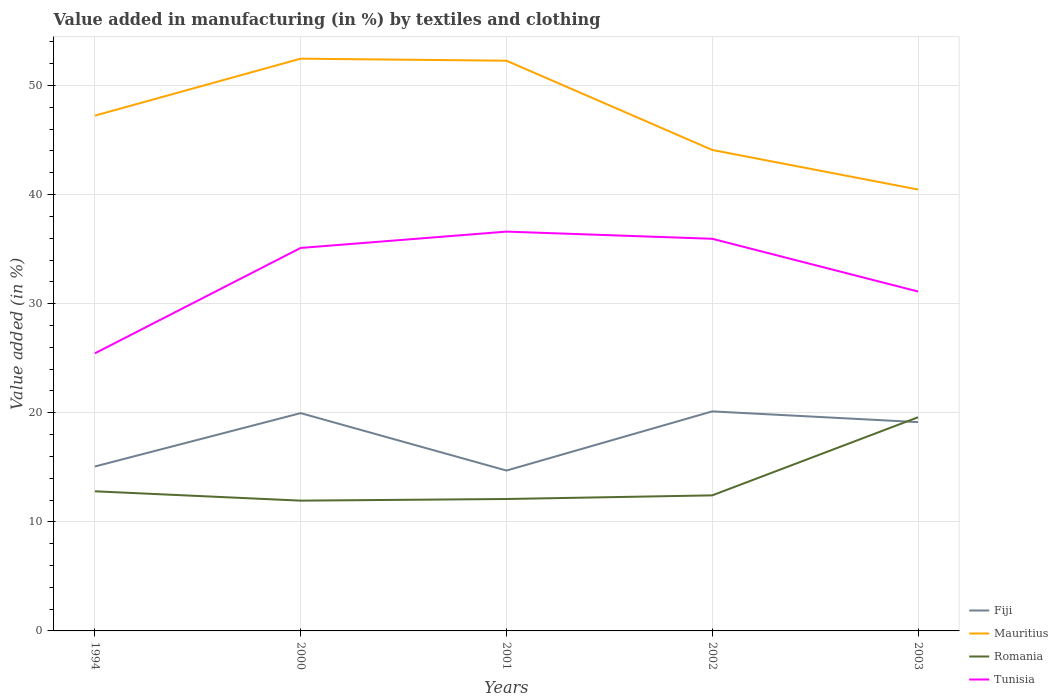Is the number of lines equal to the number of legend labels?
Your answer should be very brief. Yes. Across all years, what is the maximum percentage of value added in manufacturing by textiles and clothing in Mauritius?
Provide a succinct answer. 40.47. In which year was the percentage of value added in manufacturing by textiles and clothing in Fiji maximum?
Ensure brevity in your answer.  2001. What is the total percentage of value added in manufacturing by textiles and clothing in Fiji in the graph?
Keep it short and to the point. -5.42. What is the difference between the highest and the second highest percentage of value added in manufacturing by textiles and clothing in Mauritius?
Your answer should be very brief. 11.99. What is the difference between the highest and the lowest percentage of value added in manufacturing by textiles and clothing in Tunisia?
Your answer should be compact. 3. Is the percentage of value added in manufacturing by textiles and clothing in Mauritius strictly greater than the percentage of value added in manufacturing by textiles and clothing in Fiji over the years?
Your answer should be compact. No. How many lines are there?
Your answer should be very brief. 4. What is the difference between two consecutive major ticks on the Y-axis?
Your answer should be compact. 10. Does the graph contain any zero values?
Make the answer very short. No. Does the graph contain grids?
Give a very brief answer. Yes. Where does the legend appear in the graph?
Offer a terse response. Bottom right. How are the legend labels stacked?
Ensure brevity in your answer.  Vertical. What is the title of the graph?
Provide a succinct answer. Value added in manufacturing (in %) by textiles and clothing. Does "Uganda" appear as one of the legend labels in the graph?
Give a very brief answer. No. What is the label or title of the X-axis?
Offer a very short reply. Years. What is the label or title of the Y-axis?
Offer a very short reply. Value added (in %). What is the Value added (in %) of Fiji in 1994?
Offer a very short reply. 15.07. What is the Value added (in %) in Mauritius in 1994?
Your answer should be compact. 47.24. What is the Value added (in %) of Romania in 1994?
Offer a terse response. 12.8. What is the Value added (in %) of Tunisia in 1994?
Make the answer very short. 25.45. What is the Value added (in %) in Fiji in 2000?
Make the answer very short. 19.97. What is the Value added (in %) in Mauritius in 2000?
Provide a succinct answer. 52.46. What is the Value added (in %) of Romania in 2000?
Offer a terse response. 11.94. What is the Value added (in %) of Tunisia in 2000?
Your response must be concise. 35.11. What is the Value added (in %) of Fiji in 2001?
Make the answer very short. 14.7. What is the Value added (in %) in Mauritius in 2001?
Offer a very short reply. 52.27. What is the Value added (in %) of Romania in 2001?
Give a very brief answer. 12.09. What is the Value added (in %) of Tunisia in 2001?
Make the answer very short. 36.61. What is the Value added (in %) in Fiji in 2002?
Offer a very short reply. 20.13. What is the Value added (in %) in Mauritius in 2002?
Your answer should be compact. 44.09. What is the Value added (in %) of Romania in 2002?
Provide a short and direct response. 12.43. What is the Value added (in %) of Tunisia in 2002?
Your answer should be very brief. 35.95. What is the Value added (in %) in Fiji in 2003?
Make the answer very short. 19.14. What is the Value added (in %) of Mauritius in 2003?
Give a very brief answer. 40.47. What is the Value added (in %) in Romania in 2003?
Offer a terse response. 19.59. What is the Value added (in %) of Tunisia in 2003?
Provide a short and direct response. 31.11. Across all years, what is the maximum Value added (in %) of Fiji?
Keep it short and to the point. 20.13. Across all years, what is the maximum Value added (in %) of Mauritius?
Your answer should be compact. 52.46. Across all years, what is the maximum Value added (in %) of Romania?
Offer a terse response. 19.59. Across all years, what is the maximum Value added (in %) of Tunisia?
Offer a very short reply. 36.61. Across all years, what is the minimum Value added (in %) in Fiji?
Offer a terse response. 14.7. Across all years, what is the minimum Value added (in %) in Mauritius?
Your answer should be compact. 40.47. Across all years, what is the minimum Value added (in %) in Romania?
Keep it short and to the point. 11.94. Across all years, what is the minimum Value added (in %) of Tunisia?
Make the answer very short. 25.45. What is the total Value added (in %) in Fiji in the graph?
Offer a terse response. 89.01. What is the total Value added (in %) of Mauritius in the graph?
Provide a short and direct response. 236.53. What is the total Value added (in %) in Romania in the graph?
Your answer should be very brief. 68.85. What is the total Value added (in %) of Tunisia in the graph?
Your answer should be very brief. 164.22. What is the difference between the Value added (in %) in Fiji in 1994 and that in 2000?
Your answer should be very brief. -4.89. What is the difference between the Value added (in %) in Mauritius in 1994 and that in 2000?
Give a very brief answer. -5.22. What is the difference between the Value added (in %) of Romania in 1994 and that in 2000?
Your answer should be very brief. 0.86. What is the difference between the Value added (in %) in Tunisia in 1994 and that in 2000?
Keep it short and to the point. -9.66. What is the difference between the Value added (in %) in Fiji in 1994 and that in 2001?
Provide a succinct answer. 0.37. What is the difference between the Value added (in %) in Mauritius in 1994 and that in 2001?
Provide a succinct answer. -5.04. What is the difference between the Value added (in %) of Romania in 1994 and that in 2001?
Your response must be concise. 0.71. What is the difference between the Value added (in %) in Tunisia in 1994 and that in 2001?
Make the answer very short. -11.16. What is the difference between the Value added (in %) of Fiji in 1994 and that in 2002?
Give a very brief answer. -5.05. What is the difference between the Value added (in %) in Mauritius in 1994 and that in 2002?
Provide a short and direct response. 3.15. What is the difference between the Value added (in %) in Romania in 1994 and that in 2002?
Give a very brief answer. 0.37. What is the difference between the Value added (in %) in Tunisia in 1994 and that in 2002?
Offer a terse response. -10.5. What is the difference between the Value added (in %) in Fiji in 1994 and that in 2003?
Offer a very short reply. -4.07. What is the difference between the Value added (in %) in Mauritius in 1994 and that in 2003?
Your answer should be very brief. 6.77. What is the difference between the Value added (in %) of Romania in 1994 and that in 2003?
Make the answer very short. -6.79. What is the difference between the Value added (in %) in Tunisia in 1994 and that in 2003?
Ensure brevity in your answer.  -5.67. What is the difference between the Value added (in %) in Fiji in 2000 and that in 2001?
Your answer should be very brief. 5.26. What is the difference between the Value added (in %) in Mauritius in 2000 and that in 2001?
Give a very brief answer. 0.19. What is the difference between the Value added (in %) in Romania in 2000 and that in 2001?
Give a very brief answer. -0.15. What is the difference between the Value added (in %) in Tunisia in 2000 and that in 2001?
Provide a short and direct response. -1.5. What is the difference between the Value added (in %) in Fiji in 2000 and that in 2002?
Offer a very short reply. -0.16. What is the difference between the Value added (in %) in Mauritius in 2000 and that in 2002?
Offer a very short reply. 8.37. What is the difference between the Value added (in %) of Romania in 2000 and that in 2002?
Your answer should be compact. -0.48. What is the difference between the Value added (in %) of Tunisia in 2000 and that in 2002?
Provide a short and direct response. -0.84. What is the difference between the Value added (in %) of Fiji in 2000 and that in 2003?
Make the answer very short. 0.82. What is the difference between the Value added (in %) in Mauritius in 2000 and that in 2003?
Provide a short and direct response. 11.99. What is the difference between the Value added (in %) of Romania in 2000 and that in 2003?
Make the answer very short. -7.64. What is the difference between the Value added (in %) in Tunisia in 2000 and that in 2003?
Keep it short and to the point. 3.99. What is the difference between the Value added (in %) of Fiji in 2001 and that in 2002?
Your response must be concise. -5.42. What is the difference between the Value added (in %) of Mauritius in 2001 and that in 2002?
Offer a terse response. 8.18. What is the difference between the Value added (in %) of Romania in 2001 and that in 2002?
Provide a succinct answer. -0.33. What is the difference between the Value added (in %) of Tunisia in 2001 and that in 2002?
Make the answer very short. 0.66. What is the difference between the Value added (in %) of Fiji in 2001 and that in 2003?
Make the answer very short. -4.44. What is the difference between the Value added (in %) in Mauritius in 2001 and that in 2003?
Provide a short and direct response. 11.81. What is the difference between the Value added (in %) in Romania in 2001 and that in 2003?
Ensure brevity in your answer.  -7.49. What is the difference between the Value added (in %) of Tunisia in 2001 and that in 2003?
Keep it short and to the point. 5.49. What is the difference between the Value added (in %) of Fiji in 2002 and that in 2003?
Your response must be concise. 0.98. What is the difference between the Value added (in %) of Mauritius in 2002 and that in 2003?
Your answer should be very brief. 3.63. What is the difference between the Value added (in %) in Romania in 2002 and that in 2003?
Keep it short and to the point. -7.16. What is the difference between the Value added (in %) of Tunisia in 2002 and that in 2003?
Ensure brevity in your answer.  4.83. What is the difference between the Value added (in %) of Fiji in 1994 and the Value added (in %) of Mauritius in 2000?
Provide a short and direct response. -37.39. What is the difference between the Value added (in %) of Fiji in 1994 and the Value added (in %) of Romania in 2000?
Provide a succinct answer. 3.13. What is the difference between the Value added (in %) of Fiji in 1994 and the Value added (in %) of Tunisia in 2000?
Your answer should be compact. -20.04. What is the difference between the Value added (in %) of Mauritius in 1994 and the Value added (in %) of Romania in 2000?
Provide a short and direct response. 35.29. What is the difference between the Value added (in %) in Mauritius in 1994 and the Value added (in %) in Tunisia in 2000?
Provide a short and direct response. 12.13. What is the difference between the Value added (in %) in Romania in 1994 and the Value added (in %) in Tunisia in 2000?
Provide a short and direct response. -22.31. What is the difference between the Value added (in %) of Fiji in 1994 and the Value added (in %) of Mauritius in 2001?
Ensure brevity in your answer.  -37.2. What is the difference between the Value added (in %) in Fiji in 1994 and the Value added (in %) in Romania in 2001?
Offer a terse response. 2.98. What is the difference between the Value added (in %) in Fiji in 1994 and the Value added (in %) in Tunisia in 2001?
Ensure brevity in your answer.  -21.53. What is the difference between the Value added (in %) of Mauritius in 1994 and the Value added (in %) of Romania in 2001?
Give a very brief answer. 35.14. What is the difference between the Value added (in %) in Mauritius in 1994 and the Value added (in %) in Tunisia in 2001?
Your answer should be very brief. 10.63. What is the difference between the Value added (in %) of Romania in 1994 and the Value added (in %) of Tunisia in 2001?
Keep it short and to the point. -23.81. What is the difference between the Value added (in %) of Fiji in 1994 and the Value added (in %) of Mauritius in 2002?
Offer a very short reply. -29.02. What is the difference between the Value added (in %) of Fiji in 1994 and the Value added (in %) of Romania in 2002?
Ensure brevity in your answer.  2.64. What is the difference between the Value added (in %) in Fiji in 1994 and the Value added (in %) in Tunisia in 2002?
Ensure brevity in your answer.  -20.88. What is the difference between the Value added (in %) of Mauritius in 1994 and the Value added (in %) of Romania in 2002?
Ensure brevity in your answer.  34.81. What is the difference between the Value added (in %) in Mauritius in 1994 and the Value added (in %) in Tunisia in 2002?
Offer a very short reply. 11.29. What is the difference between the Value added (in %) in Romania in 1994 and the Value added (in %) in Tunisia in 2002?
Your answer should be compact. -23.15. What is the difference between the Value added (in %) of Fiji in 1994 and the Value added (in %) of Mauritius in 2003?
Give a very brief answer. -25.39. What is the difference between the Value added (in %) in Fiji in 1994 and the Value added (in %) in Romania in 2003?
Offer a terse response. -4.51. What is the difference between the Value added (in %) of Fiji in 1994 and the Value added (in %) of Tunisia in 2003?
Give a very brief answer. -16.04. What is the difference between the Value added (in %) of Mauritius in 1994 and the Value added (in %) of Romania in 2003?
Provide a succinct answer. 27.65. What is the difference between the Value added (in %) of Mauritius in 1994 and the Value added (in %) of Tunisia in 2003?
Your answer should be very brief. 16.12. What is the difference between the Value added (in %) in Romania in 1994 and the Value added (in %) in Tunisia in 2003?
Keep it short and to the point. -18.31. What is the difference between the Value added (in %) of Fiji in 2000 and the Value added (in %) of Mauritius in 2001?
Provide a succinct answer. -32.31. What is the difference between the Value added (in %) of Fiji in 2000 and the Value added (in %) of Romania in 2001?
Provide a succinct answer. 7.87. What is the difference between the Value added (in %) of Fiji in 2000 and the Value added (in %) of Tunisia in 2001?
Provide a short and direct response. -16.64. What is the difference between the Value added (in %) of Mauritius in 2000 and the Value added (in %) of Romania in 2001?
Your answer should be compact. 40.37. What is the difference between the Value added (in %) in Mauritius in 2000 and the Value added (in %) in Tunisia in 2001?
Provide a succinct answer. 15.85. What is the difference between the Value added (in %) of Romania in 2000 and the Value added (in %) of Tunisia in 2001?
Provide a short and direct response. -24.66. What is the difference between the Value added (in %) in Fiji in 2000 and the Value added (in %) in Mauritius in 2002?
Make the answer very short. -24.12. What is the difference between the Value added (in %) of Fiji in 2000 and the Value added (in %) of Romania in 2002?
Your answer should be compact. 7.54. What is the difference between the Value added (in %) in Fiji in 2000 and the Value added (in %) in Tunisia in 2002?
Your response must be concise. -15.98. What is the difference between the Value added (in %) in Mauritius in 2000 and the Value added (in %) in Romania in 2002?
Your answer should be compact. 40.03. What is the difference between the Value added (in %) in Mauritius in 2000 and the Value added (in %) in Tunisia in 2002?
Your answer should be very brief. 16.51. What is the difference between the Value added (in %) in Romania in 2000 and the Value added (in %) in Tunisia in 2002?
Ensure brevity in your answer.  -24. What is the difference between the Value added (in %) in Fiji in 2000 and the Value added (in %) in Mauritius in 2003?
Your answer should be very brief. -20.5. What is the difference between the Value added (in %) of Fiji in 2000 and the Value added (in %) of Romania in 2003?
Your answer should be very brief. 0.38. What is the difference between the Value added (in %) in Fiji in 2000 and the Value added (in %) in Tunisia in 2003?
Ensure brevity in your answer.  -11.15. What is the difference between the Value added (in %) in Mauritius in 2000 and the Value added (in %) in Romania in 2003?
Ensure brevity in your answer.  32.87. What is the difference between the Value added (in %) of Mauritius in 2000 and the Value added (in %) of Tunisia in 2003?
Ensure brevity in your answer.  21.35. What is the difference between the Value added (in %) in Romania in 2000 and the Value added (in %) in Tunisia in 2003?
Keep it short and to the point. -19.17. What is the difference between the Value added (in %) of Fiji in 2001 and the Value added (in %) of Mauritius in 2002?
Your response must be concise. -29.39. What is the difference between the Value added (in %) of Fiji in 2001 and the Value added (in %) of Romania in 2002?
Your answer should be compact. 2.27. What is the difference between the Value added (in %) in Fiji in 2001 and the Value added (in %) in Tunisia in 2002?
Provide a succinct answer. -21.25. What is the difference between the Value added (in %) in Mauritius in 2001 and the Value added (in %) in Romania in 2002?
Ensure brevity in your answer.  39.85. What is the difference between the Value added (in %) in Mauritius in 2001 and the Value added (in %) in Tunisia in 2002?
Your answer should be compact. 16.33. What is the difference between the Value added (in %) of Romania in 2001 and the Value added (in %) of Tunisia in 2002?
Ensure brevity in your answer.  -23.85. What is the difference between the Value added (in %) in Fiji in 2001 and the Value added (in %) in Mauritius in 2003?
Your response must be concise. -25.76. What is the difference between the Value added (in %) in Fiji in 2001 and the Value added (in %) in Romania in 2003?
Ensure brevity in your answer.  -4.88. What is the difference between the Value added (in %) in Fiji in 2001 and the Value added (in %) in Tunisia in 2003?
Your answer should be very brief. -16.41. What is the difference between the Value added (in %) of Mauritius in 2001 and the Value added (in %) of Romania in 2003?
Keep it short and to the point. 32.69. What is the difference between the Value added (in %) in Mauritius in 2001 and the Value added (in %) in Tunisia in 2003?
Offer a very short reply. 21.16. What is the difference between the Value added (in %) of Romania in 2001 and the Value added (in %) of Tunisia in 2003?
Offer a terse response. -19.02. What is the difference between the Value added (in %) in Fiji in 2002 and the Value added (in %) in Mauritius in 2003?
Ensure brevity in your answer.  -20.34. What is the difference between the Value added (in %) in Fiji in 2002 and the Value added (in %) in Romania in 2003?
Your answer should be compact. 0.54. What is the difference between the Value added (in %) in Fiji in 2002 and the Value added (in %) in Tunisia in 2003?
Provide a short and direct response. -10.99. What is the difference between the Value added (in %) in Mauritius in 2002 and the Value added (in %) in Romania in 2003?
Offer a terse response. 24.5. What is the difference between the Value added (in %) in Mauritius in 2002 and the Value added (in %) in Tunisia in 2003?
Your answer should be very brief. 12.98. What is the difference between the Value added (in %) in Romania in 2002 and the Value added (in %) in Tunisia in 2003?
Offer a terse response. -18.69. What is the average Value added (in %) of Fiji per year?
Your answer should be compact. 17.8. What is the average Value added (in %) in Mauritius per year?
Ensure brevity in your answer.  47.3. What is the average Value added (in %) in Romania per year?
Provide a short and direct response. 13.77. What is the average Value added (in %) in Tunisia per year?
Ensure brevity in your answer.  32.84. In the year 1994, what is the difference between the Value added (in %) of Fiji and Value added (in %) of Mauritius?
Offer a very short reply. -32.17. In the year 1994, what is the difference between the Value added (in %) of Fiji and Value added (in %) of Romania?
Make the answer very short. 2.27. In the year 1994, what is the difference between the Value added (in %) in Fiji and Value added (in %) in Tunisia?
Provide a short and direct response. -10.38. In the year 1994, what is the difference between the Value added (in %) in Mauritius and Value added (in %) in Romania?
Ensure brevity in your answer.  34.44. In the year 1994, what is the difference between the Value added (in %) in Mauritius and Value added (in %) in Tunisia?
Your answer should be compact. 21.79. In the year 1994, what is the difference between the Value added (in %) of Romania and Value added (in %) of Tunisia?
Give a very brief answer. -12.65. In the year 2000, what is the difference between the Value added (in %) in Fiji and Value added (in %) in Mauritius?
Your answer should be very brief. -32.49. In the year 2000, what is the difference between the Value added (in %) of Fiji and Value added (in %) of Romania?
Your answer should be compact. 8.02. In the year 2000, what is the difference between the Value added (in %) of Fiji and Value added (in %) of Tunisia?
Offer a terse response. -15.14. In the year 2000, what is the difference between the Value added (in %) of Mauritius and Value added (in %) of Romania?
Your answer should be very brief. 40.52. In the year 2000, what is the difference between the Value added (in %) in Mauritius and Value added (in %) in Tunisia?
Ensure brevity in your answer.  17.35. In the year 2000, what is the difference between the Value added (in %) in Romania and Value added (in %) in Tunisia?
Ensure brevity in your answer.  -23.16. In the year 2001, what is the difference between the Value added (in %) in Fiji and Value added (in %) in Mauritius?
Your answer should be very brief. -37.57. In the year 2001, what is the difference between the Value added (in %) in Fiji and Value added (in %) in Romania?
Ensure brevity in your answer.  2.61. In the year 2001, what is the difference between the Value added (in %) in Fiji and Value added (in %) in Tunisia?
Provide a succinct answer. -21.9. In the year 2001, what is the difference between the Value added (in %) of Mauritius and Value added (in %) of Romania?
Your answer should be compact. 40.18. In the year 2001, what is the difference between the Value added (in %) of Mauritius and Value added (in %) of Tunisia?
Your answer should be very brief. 15.67. In the year 2001, what is the difference between the Value added (in %) of Romania and Value added (in %) of Tunisia?
Your answer should be compact. -24.51. In the year 2002, what is the difference between the Value added (in %) in Fiji and Value added (in %) in Mauritius?
Provide a succinct answer. -23.96. In the year 2002, what is the difference between the Value added (in %) in Fiji and Value added (in %) in Romania?
Provide a short and direct response. 7.7. In the year 2002, what is the difference between the Value added (in %) of Fiji and Value added (in %) of Tunisia?
Provide a short and direct response. -15.82. In the year 2002, what is the difference between the Value added (in %) of Mauritius and Value added (in %) of Romania?
Keep it short and to the point. 31.66. In the year 2002, what is the difference between the Value added (in %) of Mauritius and Value added (in %) of Tunisia?
Offer a terse response. 8.14. In the year 2002, what is the difference between the Value added (in %) in Romania and Value added (in %) in Tunisia?
Offer a terse response. -23.52. In the year 2003, what is the difference between the Value added (in %) in Fiji and Value added (in %) in Mauritius?
Provide a succinct answer. -21.32. In the year 2003, what is the difference between the Value added (in %) in Fiji and Value added (in %) in Romania?
Offer a terse response. -0.44. In the year 2003, what is the difference between the Value added (in %) of Fiji and Value added (in %) of Tunisia?
Offer a very short reply. -11.97. In the year 2003, what is the difference between the Value added (in %) in Mauritius and Value added (in %) in Romania?
Offer a very short reply. 20.88. In the year 2003, what is the difference between the Value added (in %) of Mauritius and Value added (in %) of Tunisia?
Provide a succinct answer. 9.35. In the year 2003, what is the difference between the Value added (in %) of Romania and Value added (in %) of Tunisia?
Your answer should be very brief. -11.53. What is the ratio of the Value added (in %) in Fiji in 1994 to that in 2000?
Your answer should be compact. 0.75. What is the ratio of the Value added (in %) in Mauritius in 1994 to that in 2000?
Ensure brevity in your answer.  0.9. What is the ratio of the Value added (in %) of Romania in 1994 to that in 2000?
Give a very brief answer. 1.07. What is the ratio of the Value added (in %) in Tunisia in 1994 to that in 2000?
Provide a succinct answer. 0.72. What is the ratio of the Value added (in %) in Fiji in 1994 to that in 2001?
Ensure brevity in your answer.  1.03. What is the ratio of the Value added (in %) of Mauritius in 1994 to that in 2001?
Offer a very short reply. 0.9. What is the ratio of the Value added (in %) in Romania in 1994 to that in 2001?
Your answer should be very brief. 1.06. What is the ratio of the Value added (in %) of Tunisia in 1994 to that in 2001?
Your answer should be very brief. 0.7. What is the ratio of the Value added (in %) of Fiji in 1994 to that in 2002?
Offer a terse response. 0.75. What is the ratio of the Value added (in %) of Mauritius in 1994 to that in 2002?
Provide a succinct answer. 1.07. What is the ratio of the Value added (in %) of Romania in 1994 to that in 2002?
Your answer should be compact. 1.03. What is the ratio of the Value added (in %) of Tunisia in 1994 to that in 2002?
Give a very brief answer. 0.71. What is the ratio of the Value added (in %) in Fiji in 1994 to that in 2003?
Ensure brevity in your answer.  0.79. What is the ratio of the Value added (in %) of Mauritius in 1994 to that in 2003?
Keep it short and to the point. 1.17. What is the ratio of the Value added (in %) of Romania in 1994 to that in 2003?
Provide a succinct answer. 0.65. What is the ratio of the Value added (in %) in Tunisia in 1994 to that in 2003?
Provide a succinct answer. 0.82. What is the ratio of the Value added (in %) in Fiji in 2000 to that in 2001?
Provide a succinct answer. 1.36. What is the ratio of the Value added (in %) of Romania in 2000 to that in 2001?
Offer a very short reply. 0.99. What is the ratio of the Value added (in %) in Tunisia in 2000 to that in 2001?
Your response must be concise. 0.96. What is the ratio of the Value added (in %) in Fiji in 2000 to that in 2002?
Offer a very short reply. 0.99. What is the ratio of the Value added (in %) in Mauritius in 2000 to that in 2002?
Keep it short and to the point. 1.19. What is the ratio of the Value added (in %) in Romania in 2000 to that in 2002?
Keep it short and to the point. 0.96. What is the ratio of the Value added (in %) in Tunisia in 2000 to that in 2002?
Your answer should be compact. 0.98. What is the ratio of the Value added (in %) of Fiji in 2000 to that in 2003?
Your answer should be very brief. 1.04. What is the ratio of the Value added (in %) of Mauritius in 2000 to that in 2003?
Offer a very short reply. 1.3. What is the ratio of the Value added (in %) in Romania in 2000 to that in 2003?
Keep it short and to the point. 0.61. What is the ratio of the Value added (in %) of Tunisia in 2000 to that in 2003?
Ensure brevity in your answer.  1.13. What is the ratio of the Value added (in %) in Fiji in 2001 to that in 2002?
Offer a very short reply. 0.73. What is the ratio of the Value added (in %) of Mauritius in 2001 to that in 2002?
Provide a succinct answer. 1.19. What is the ratio of the Value added (in %) in Romania in 2001 to that in 2002?
Give a very brief answer. 0.97. What is the ratio of the Value added (in %) of Tunisia in 2001 to that in 2002?
Offer a very short reply. 1.02. What is the ratio of the Value added (in %) of Fiji in 2001 to that in 2003?
Give a very brief answer. 0.77. What is the ratio of the Value added (in %) in Mauritius in 2001 to that in 2003?
Provide a succinct answer. 1.29. What is the ratio of the Value added (in %) of Romania in 2001 to that in 2003?
Your answer should be very brief. 0.62. What is the ratio of the Value added (in %) of Tunisia in 2001 to that in 2003?
Your answer should be very brief. 1.18. What is the ratio of the Value added (in %) in Fiji in 2002 to that in 2003?
Your answer should be very brief. 1.05. What is the ratio of the Value added (in %) of Mauritius in 2002 to that in 2003?
Your answer should be compact. 1.09. What is the ratio of the Value added (in %) of Romania in 2002 to that in 2003?
Provide a succinct answer. 0.63. What is the ratio of the Value added (in %) of Tunisia in 2002 to that in 2003?
Your response must be concise. 1.16. What is the difference between the highest and the second highest Value added (in %) of Fiji?
Keep it short and to the point. 0.16. What is the difference between the highest and the second highest Value added (in %) of Mauritius?
Your answer should be very brief. 0.19. What is the difference between the highest and the second highest Value added (in %) in Romania?
Your answer should be compact. 6.79. What is the difference between the highest and the second highest Value added (in %) in Tunisia?
Give a very brief answer. 0.66. What is the difference between the highest and the lowest Value added (in %) in Fiji?
Your response must be concise. 5.42. What is the difference between the highest and the lowest Value added (in %) in Mauritius?
Provide a short and direct response. 11.99. What is the difference between the highest and the lowest Value added (in %) of Romania?
Your response must be concise. 7.64. What is the difference between the highest and the lowest Value added (in %) of Tunisia?
Give a very brief answer. 11.16. 